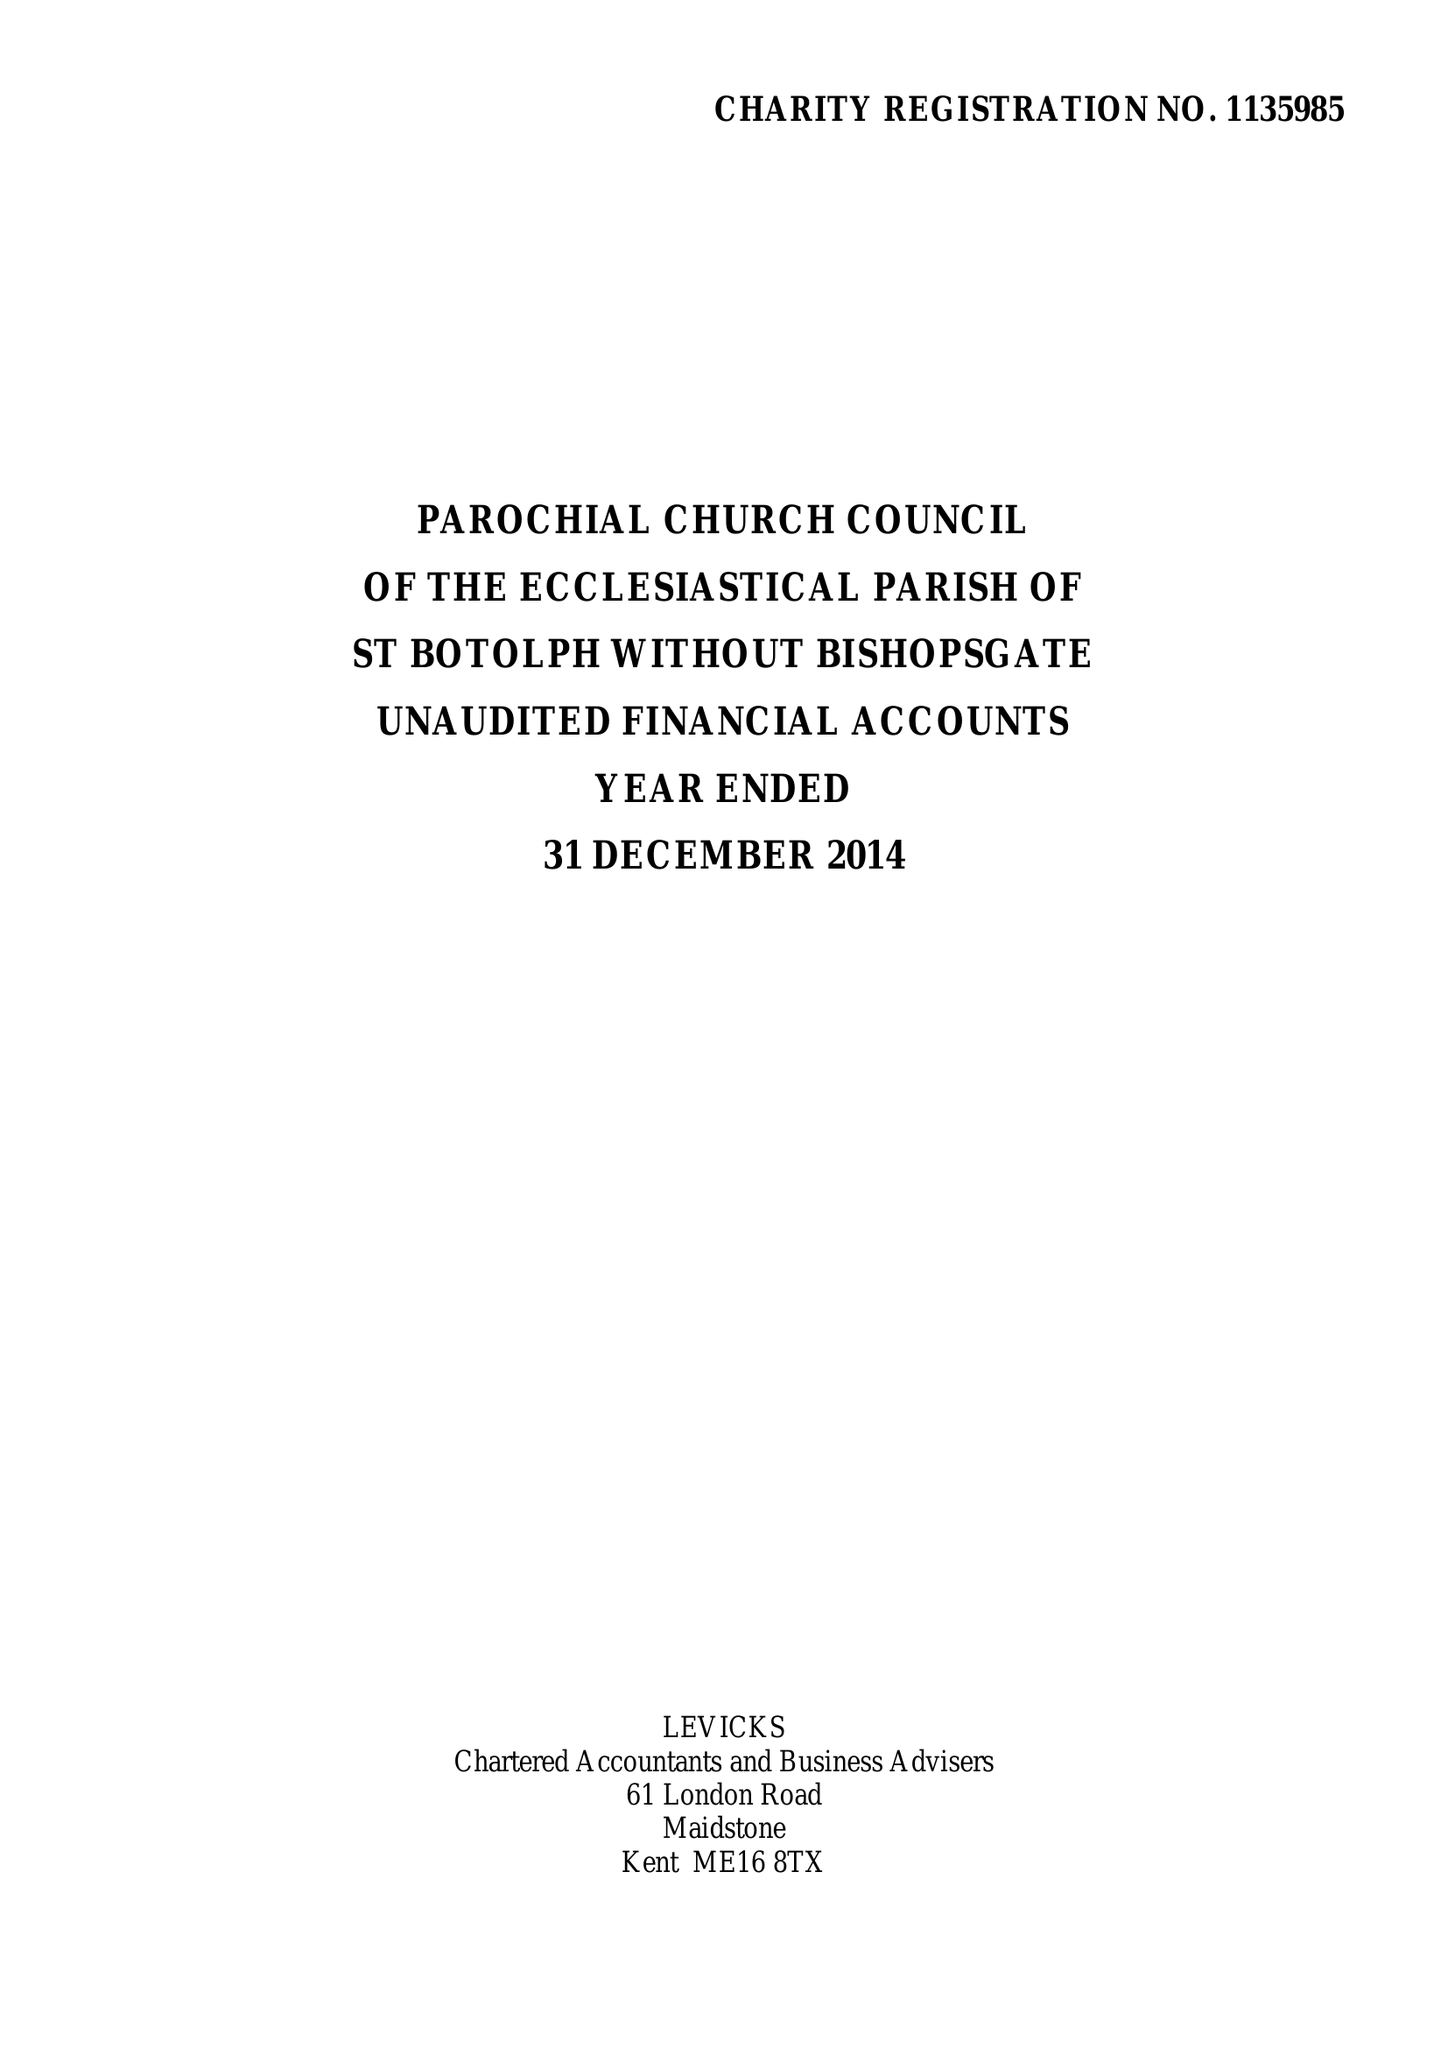What is the value for the charity_name?
Answer the question using a single word or phrase. The Parochial Church Council Of The Ecclesiastical Parish Of St Botolph-Without-Bishopsgate 